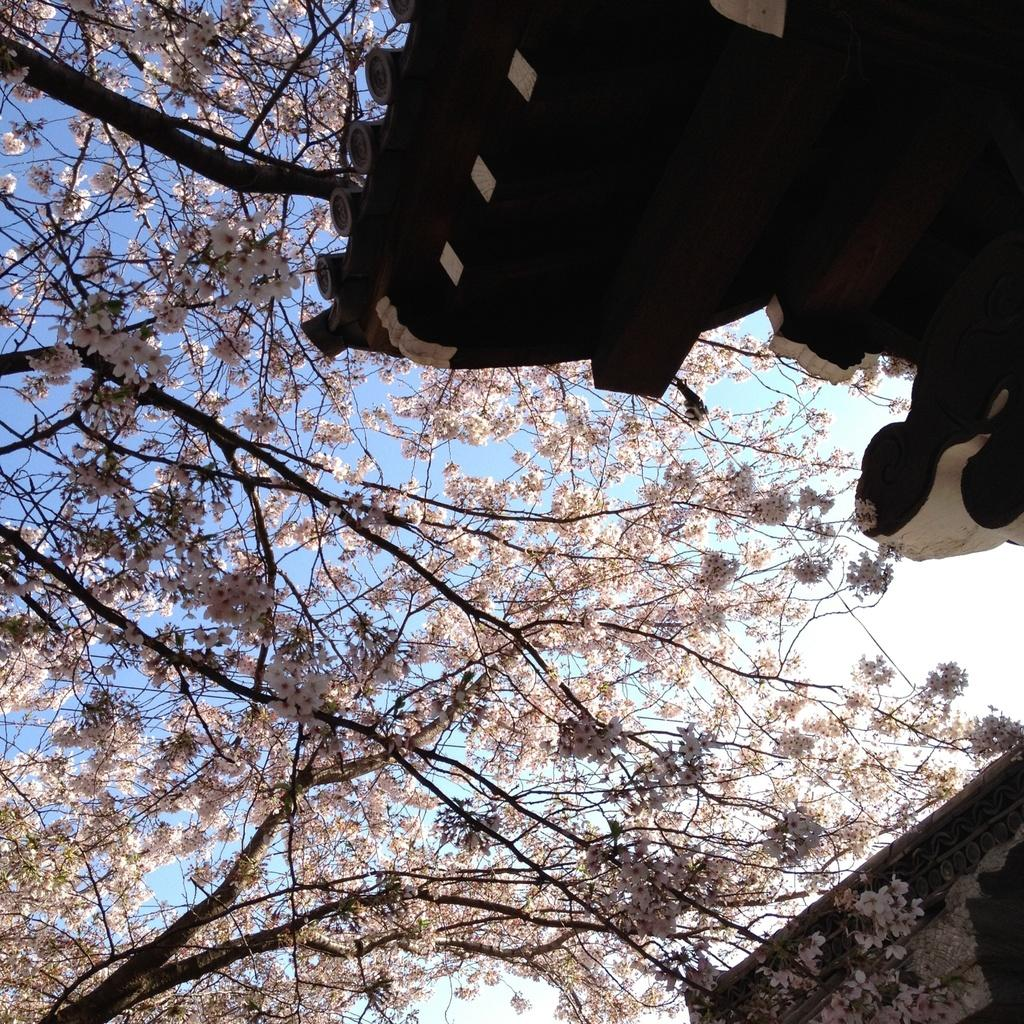What type of vegetation can be seen in the image? There are trees in the image. What type of structure is visible in the top right corner of the image? There is a building with a roof visible in the top right corner of the image. What type of building is located in the bottom right corner of the image? There is a house in the bottom right corner of the image. What is visible in the background of the image? The sky is visible in the background of the image. What can be observed in the sky in the image? Clouds are present in the background of the image. Can you tell me how many ducks are flying in the sky in the image? There are no ducks present in the image; it only features trees, a building, a house, and clouds in the sky. 